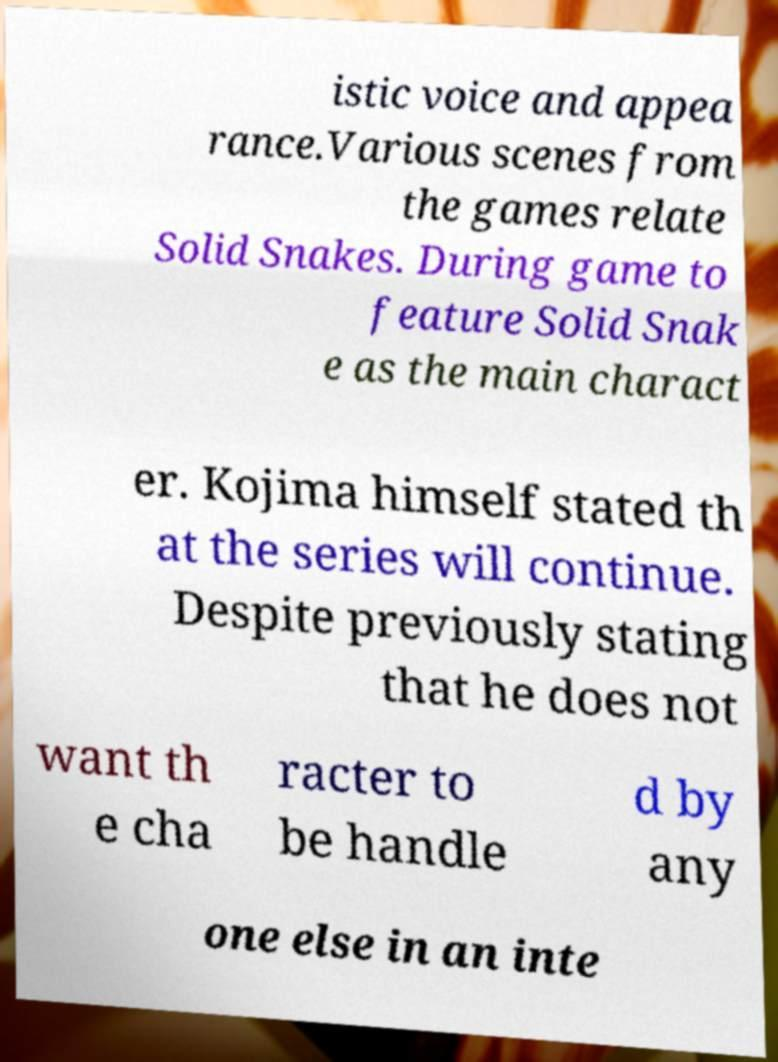For documentation purposes, I need the text within this image transcribed. Could you provide that? istic voice and appea rance.Various scenes from the games relate Solid Snakes. During game to feature Solid Snak e as the main charact er. Kojima himself stated th at the series will continue. Despite previously stating that he does not want th e cha racter to be handle d by any one else in an inte 